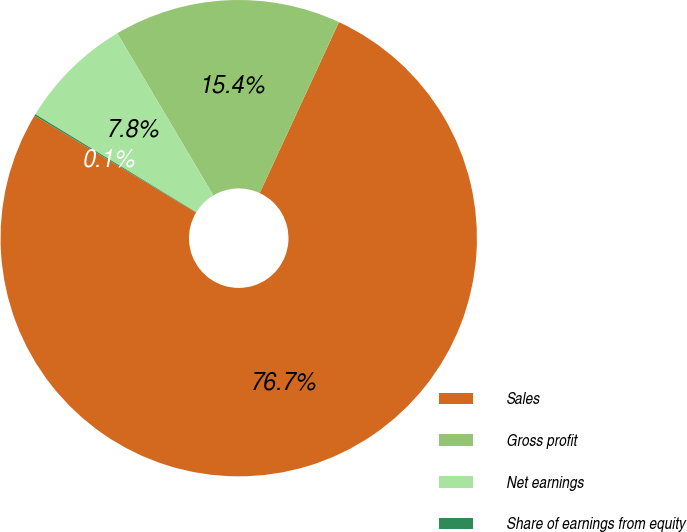Convert chart. <chart><loc_0><loc_0><loc_500><loc_500><pie_chart><fcel>Sales<fcel>Gross profit<fcel>Net earnings<fcel>Share of earnings from equity<nl><fcel>76.69%<fcel>15.43%<fcel>7.77%<fcel>0.11%<nl></chart> 